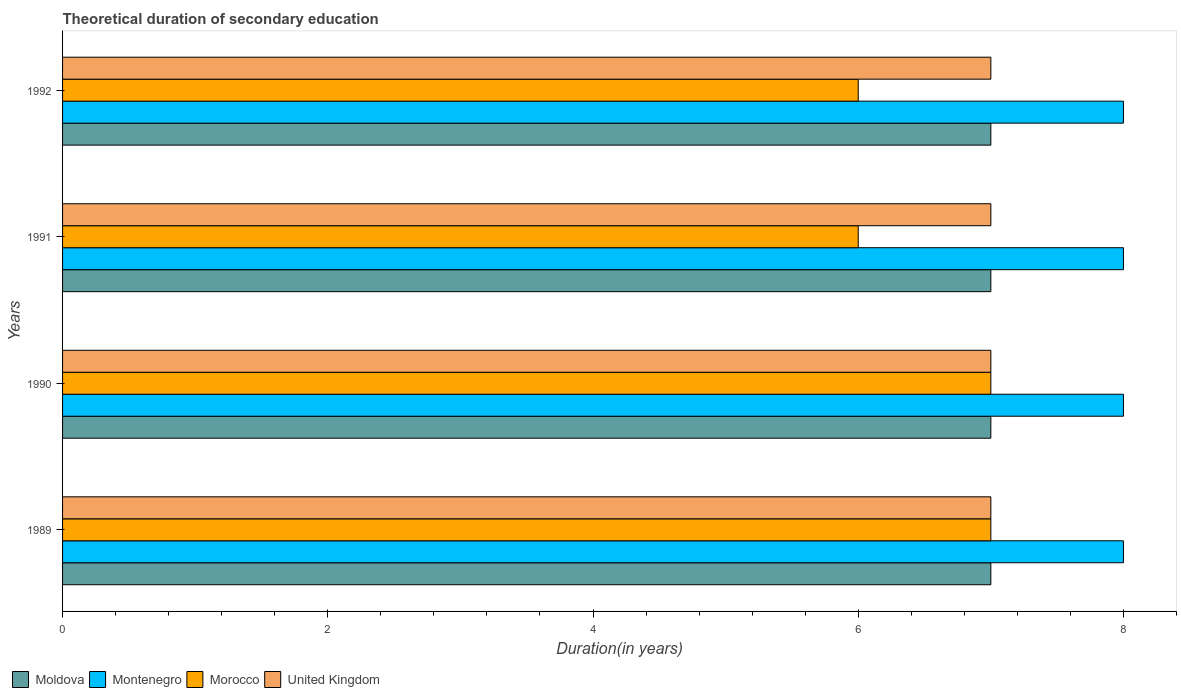How many groups of bars are there?
Offer a terse response. 4. Are the number of bars on each tick of the Y-axis equal?
Your answer should be compact. Yes. How many bars are there on the 3rd tick from the top?
Offer a very short reply. 4. How many bars are there on the 4th tick from the bottom?
Make the answer very short. 4. In how many cases, is the number of bars for a given year not equal to the number of legend labels?
Provide a succinct answer. 0. What is the total theoretical duration of secondary education in Montenegro in 1990?
Offer a very short reply. 8. Across all years, what is the maximum total theoretical duration of secondary education in Morocco?
Offer a very short reply. 7. Across all years, what is the minimum total theoretical duration of secondary education in United Kingdom?
Your answer should be compact. 7. What is the total total theoretical duration of secondary education in Morocco in the graph?
Offer a very short reply. 26. What is the difference between the total theoretical duration of secondary education in Morocco in 1991 and that in 1992?
Offer a very short reply. 0. What is the difference between the total theoretical duration of secondary education in Moldova in 1990 and the total theoretical duration of secondary education in Morocco in 1992?
Keep it short and to the point. 1. In the year 1992, what is the difference between the total theoretical duration of secondary education in Montenegro and total theoretical duration of secondary education in Moldova?
Give a very brief answer. 1. Is the total theoretical duration of secondary education in United Kingdom in 1989 less than that in 1991?
Your answer should be very brief. No. What is the difference between the highest and the lowest total theoretical duration of secondary education in United Kingdom?
Your answer should be compact. 0. In how many years, is the total theoretical duration of secondary education in United Kingdom greater than the average total theoretical duration of secondary education in United Kingdom taken over all years?
Your answer should be very brief. 0. Is the sum of the total theoretical duration of secondary education in Moldova in 1991 and 1992 greater than the maximum total theoretical duration of secondary education in United Kingdom across all years?
Ensure brevity in your answer.  Yes. Is it the case that in every year, the sum of the total theoretical duration of secondary education in Montenegro and total theoretical duration of secondary education in United Kingdom is greater than the sum of total theoretical duration of secondary education in Morocco and total theoretical duration of secondary education in Moldova?
Ensure brevity in your answer.  Yes. What does the 3rd bar from the top in 1989 represents?
Offer a terse response. Montenegro. What does the 3rd bar from the bottom in 1990 represents?
Make the answer very short. Morocco. Is it the case that in every year, the sum of the total theoretical duration of secondary education in United Kingdom and total theoretical duration of secondary education in Montenegro is greater than the total theoretical duration of secondary education in Morocco?
Keep it short and to the point. Yes. Are all the bars in the graph horizontal?
Your answer should be very brief. Yes. How many years are there in the graph?
Keep it short and to the point. 4. Are the values on the major ticks of X-axis written in scientific E-notation?
Ensure brevity in your answer.  No. Where does the legend appear in the graph?
Provide a succinct answer. Bottom left. How are the legend labels stacked?
Offer a terse response. Horizontal. What is the title of the graph?
Give a very brief answer. Theoretical duration of secondary education. Does "World" appear as one of the legend labels in the graph?
Provide a succinct answer. No. What is the label or title of the X-axis?
Provide a succinct answer. Duration(in years). What is the label or title of the Y-axis?
Your answer should be compact. Years. What is the Duration(in years) of Moldova in 1989?
Keep it short and to the point. 7. What is the Duration(in years) in Montenegro in 1990?
Offer a terse response. 8. What is the Duration(in years) in United Kingdom in 1990?
Your response must be concise. 7. What is the Duration(in years) of Moldova in 1991?
Your answer should be compact. 7. What is the Duration(in years) of Montenegro in 1991?
Offer a terse response. 8. What is the Duration(in years) in Morocco in 1991?
Keep it short and to the point. 6. What is the Duration(in years) in Moldova in 1992?
Provide a succinct answer. 7. What is the Duration(in years) of Montenegro in 1992?
Your answer should be very brief. 8. Across all years, what is the maximum Duration(in years) of Moldova?
Your answer should be very brief. 7. Across all years, what is the maximum Duration(in years) of Montenegro?
Your answer should be compact. 8. Across all years, what is the minimum Duration(in years) of Montenegro?
Offer a terse response. 8. Across all years, what is the minimum Duration(in years) in Morocco?
Provide a short and direct response. 6. Across all years, what is the minimum Duration(in years) in United Kingdom?
Offer a very short reply. 7. What is the total Duration(in years) in United Kingdom in the graph?
Your response must be concise. 28. What is the difference between the Duration(in years) of Moldova in 1989 and that in 1990?
Make the answer very short. 0. What is the difference between the Duration(in years) of Montenegro in 1989 and that in 1990?
Provide a succinct answer. 0. What is the difference between the Duration(in years) in United Kingdom in 1989 and that in 1990?
Your answer should be compact. 0. What is the difference between the Duration(in years) in Montenegro in 1989 and that in 1991?
Provide a succinct answer. 0. What is the difference between the Duration(in years) in Moldova in 1990 and that in 1991?
Ensure brevity in your answer.  0. What is the difference between the Duration(in years) in United Kingdom in 1990 and that in 1991?
Provide a succinct answer. 0. What is the difference between the Duration(in years) in Montenegro in 1990 and that in 1992?
Offer a very short reply. 0. What is the difference between the Duration(in years) of Morocco in 1990 and that in 1992?
Offer a very short reply. 1. What is the difference between the Duration(in years) in Moldova in 1991 and that in 1992?
Offer a very short reply. 0. What is the difference between the Duration(in years) in Montenegro in 1991 and that in 1992?
Your response must be concise. 0. What is the difference between the Duration(in years) of United Kingdom in 1991 and that in 1992?
Offer a terse response. 0. What is the difference between the Duration(in years) of Moldova in 1989 and the Duration(in years) of Morocco in 1990?
Offer a very short reply. 0. What is the difference between the Duration(in years) of Moldova in 1989 and the Duration(in years) of United Kingdom in 1990?
Give a very brief answer. 0. What is the difference between the Duration(in years) in Moldova in 1989 and the Duration(in years) in Montenegro in 1991?
Ensure brevity in your answer.  -1. What is the difference between the Duration(in years) in Montenegro in 1989 and the Duration(in years) in United Kingdom in 1991?
Keep it short and to the point. 1. What is the difference between the Duration(in years) in Moldova in 1989 and the Duration(in years) in Morocco in 1992?
Make the answer very short. 1. What is the difference between the Duration(in years) in Moldova in 1989 and the Duration(in years) in United Kingdom in 1992?
Provide a succinct answer. 0. What is the difference between the Duration(in years) in Montenegro in 1989 and the Duration(in years) in Morocco in 1992?
Offer a very short reply. 2. What is the difference between the Duration(in years) of Moldova in 1990 and the Duration(in years) of United Kingdom in 1991?
Give a very brief answer. 0. What is the difference between the Duration(in years) of Morocco in 1990 and the Duration(in years) of United Kingdom in 1991?
Your response must be concise. 0. What is the difference between the Duration(in years) of Moldova in 1990 and the Duration(in years) of Montenegro in 1992?
Your answer should be very brief. -1. What is the difference between the Duration(in years) in Morocco in 1990 and the Duration(in years) in United Kingdom in 1992?
Your answer should be very brief. 0. What is the difference between the Duration(in years) in Moldova in 1991 and the Duration(in years) in Montenegro in 1992?
Your answer should be very brief. -1. What is the difference between the Duration(in years) of Moldova in 1991 and the Duration(in years) of United Kingdom in 1992?
Provide a succinct answer. 0. What is the difference between the Duration(in years) of Montenegro in 1991 and the Duration(in years) of Morocco in 1992?
Offer a terse response. 2. What is the difference between the Duration(in years) in Morocco in 1991 and the Duration(in years) in United Kingdom in 1992?
Your response must be concise. -1. What is the average Duration(in years) of Moldova per year?
Give a very brief answer. 7. In the year 1989, what is the difference between the Duration(in years) of Montenegro and Duration(in years) of Morocco?
Give a very brief answer. 1. In the year 1989, what is the difference between the Duration(in years) of Morocco and Duration(in years) of United Kingdom?
Give a very brief answer. 0. In the year 1990, what is the difference between the Duration(in years) in Moldova and Duration(in years) in Morocco?
Give a very brief answer. 0. In the year 1990, what is the difference between the Duration(in years) in Moldova and Duration(in years) in United Kingdom?
Provide a short and direct response. 0. In the year 1991, what is the difference between the Duration(in years) in Montenegro and Duration(in years) in Morocco?
Keep it short and to the point. 2. In the year 1991, what is the difference between the Duration(in years) in Morocco and Duration(in years) in United Kingdom?
Ensure brevity in your answer.  -1. In the year 1992, what is the difference between the Duration(in years) of Moldova and Duration(in years) of Montenegro?
Give a very brief answer. -1. In the year 1992, what is the difference between the Duration(in years) of Moldova and Duration(in years) of United Kingdom?
Provide a succinct answer. 0. In the year 1992, what is the difference between the Duration(in years) of Montenegro and Duration(in years) of United Kingdom?
Make the answer very short. 1. In the year 1992, what is the difference between the Duration(in years) of Morocco and Duration(in years) of United Kingdom?
Offer a terse response. -1. What is the ratio of the Duration(in years) in United Kingdom in 1989 to that in 1990?
Offer a very short reply. 1. What is the ratio of the Duration(in years) of Montenegro in 1989 to that in 1991?
Your response must be concise. 1. What is the ratio of the Duration(in years) of Moldova in 1989 to that in 1992?
Offer a terse response. 1. What is the ratio of the Duration(in years) of Moldova in 1990 to that in 1991?
Offer a very short reply. 1. What is the ratio of the Duration(in years) of Montenegro in 1990 to that in 1991?
Keep it short and to the point. 1. What is the ratio of the Duration(in years) of Morocco in 1990 to that in 1991?
Keep it short and to the point. 1.17. What is the ratio of the Duration(in years) in United Kingdom in 1990 to that in 1991?
Provide a succinct answer. 1. What is the ratio of the Duration(in years) in Moldova in 1990 to that in 1992?
Provide a succinct answer. 1. What is the ratio of the Duration(in years) of Morocco in 1990 to that in 1992?
Offer a very short reply. 1.17. What is the ratio of the Duration(in years) of United Kingdom in 1990 to that in 1992?
Your answer should be very brief. 1. What is the ratio of the Duration(in years) in Moldova in 1991 to that in 1992?
Make the answer very short. 1. What is the ratio of the Duration(in years) in Morocco in 1991 to that in 1992?
Your answer should be compact. 1. What is the ratio of the Duration(in years) in United Kingdom in 1991 to that in 1992?
Keep it short and to the point. 1. What is the difference between the highest and the second highest Duration(in years) of Moldova?
Give a very brief answer. 0. What is the difference between the highest and the second highest Duration(in years) of Montenegro?
Make the answer very short. 0. What is the difference between the highest and the second highest Duration(in years) in Morocco?
Ensure brevity in your answer.  0. What is the difference between the highest and the second highest Duration(in years) in United Kingdom?
Your response must be concise. 0. 